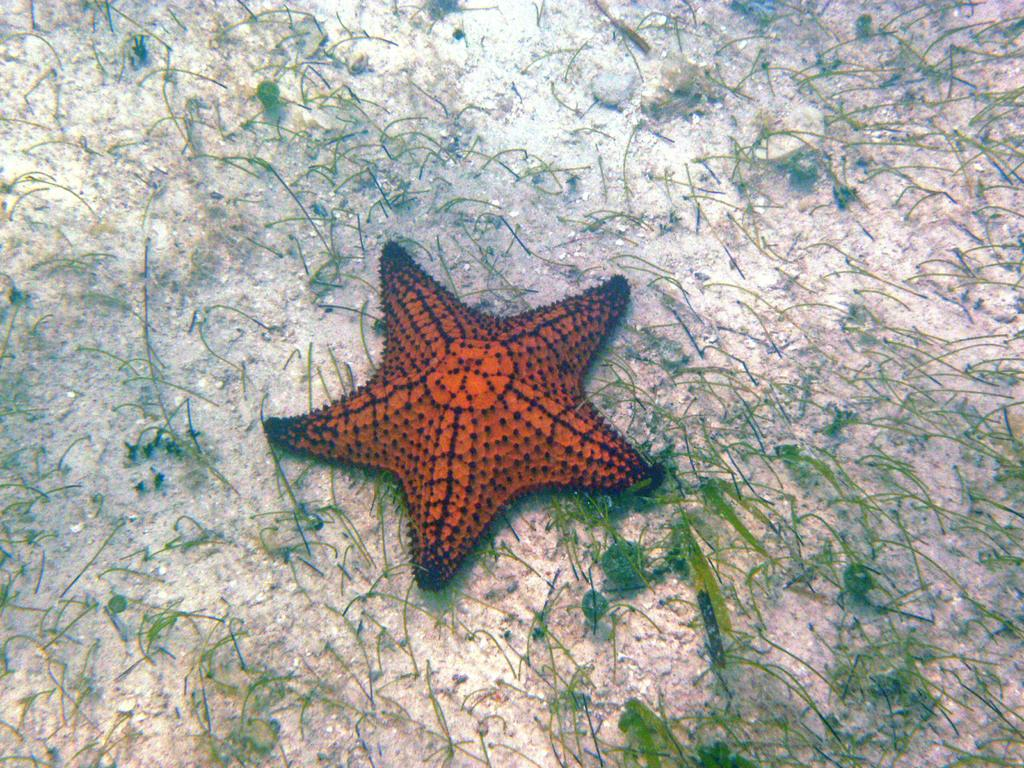What type of marine animal is present in the image? There is a starfish in the image. What type of vegetation can be seen in the image? There is grass in the image. What type of terrain is visible in the water? There is sand in the water in the image. What type of glue is being used to hold the starfish in the image? There is no glue present in the image; the starfish is naturally situated in its environment. 